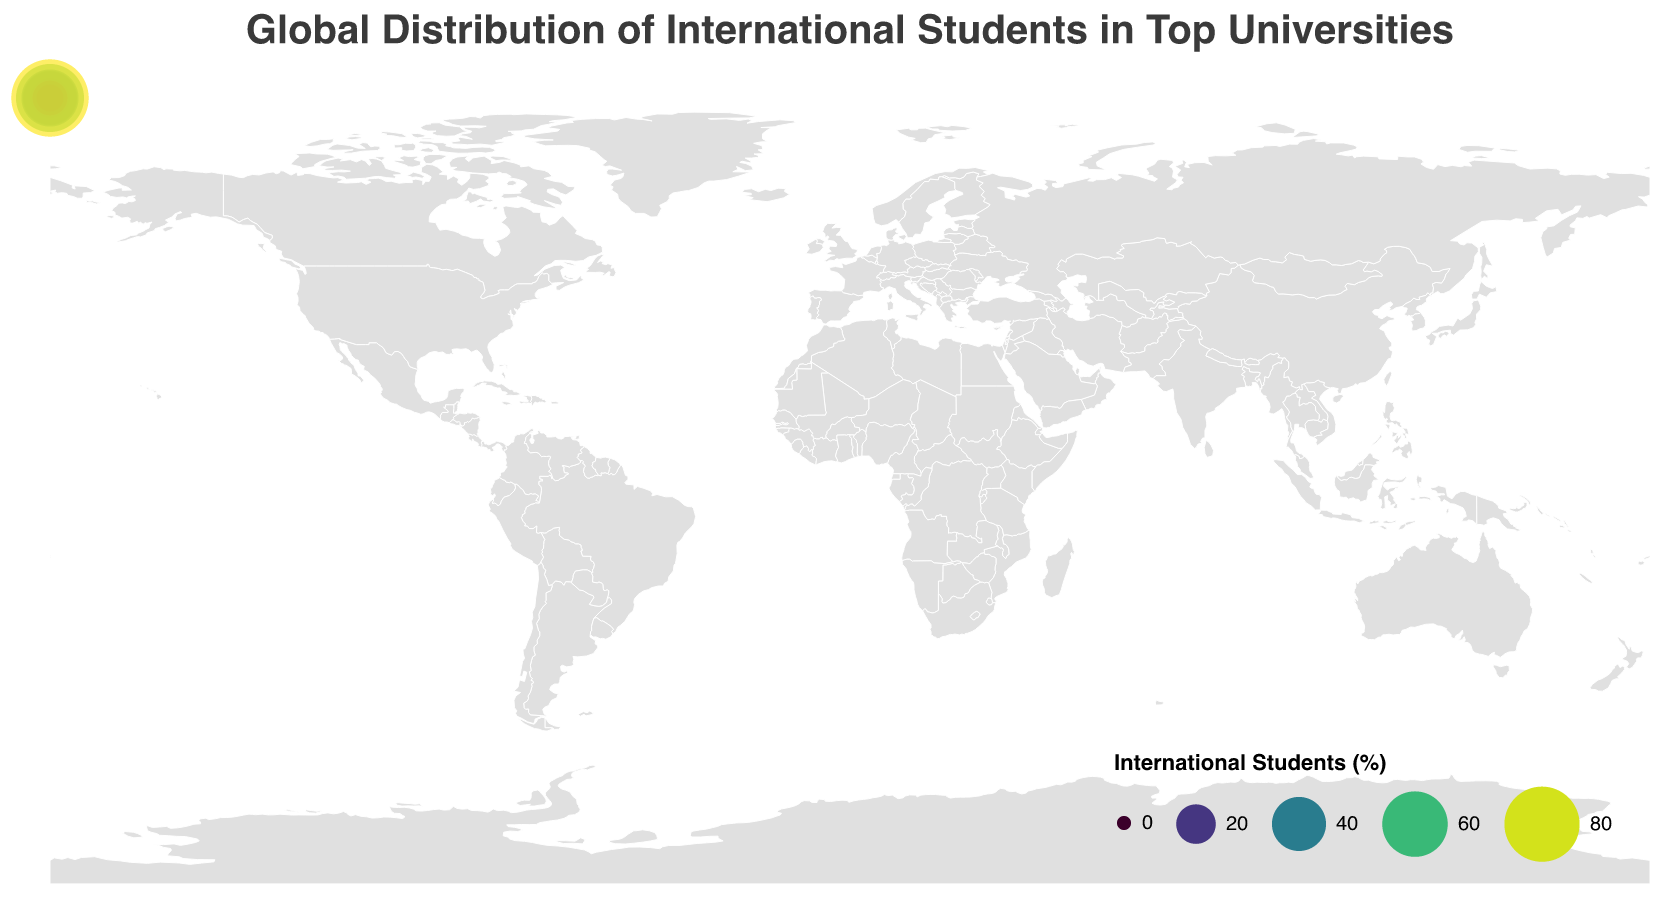what is the title of the figure? The title is written at the top of the figure and specifies the subject of the data being displayed.
Answer: "Global Distribution of International Students in Top Universities" Which university has the highest percentage of international students? By examining the size and color of the circles, the largest and most intense color indicates the highest value.
Answer: New York University Abu Dhabi Which countries have a university with an international student percentage above 40%? The countries corresponding to universities with circles that fall in the range above 40% based on the color scale and size.
Answer: United Arab Emirates, Spain, France, United Kingdom, Switzerland, and Australia What is the percentage of international students at University of Oxford? Locate University of Oxford on the plot and read the percentage value.
Answer: 41% How many universities have a percentage of international students less than 20%? Count the number of circles with sizes and colors indicative of less than 20%.
Answer: 7 Which university has a higher percentage of international students, University of Toronto or National University of Singapore? Compare the size and color of the circles representing University of Toronto and National University of Singapore.
Answer: University of Toronto What is the range of international student percentages shown in the plot? Identify the smallest and largest values from the plot's legend or data points.
Answer: 8% - 85% Compare the percentage of international students at Harvard University and Tsinghua University, which one is greater and by how much? Locate both universities on the plot and calculate the difference between their percentages.
Answer: Harvard University has 14% more Identify the university with a similar percentage of international students to ETH Zurich Locate ETH Zurich and identify another university with similar size and color of circle.
Answer: University of Melbourne What is the average percentage of international students among the universities in Europe? Select the relevant universities in Europe and calculate the average. List includes University of Oxford, ETH Zurich, Sciences Po, Technical University of Munich, University of Amsterdam, Bocconi University, and IE University.
Answer: (41 + 39 + 45 + 28 + 20 + 15 + 65)/7 ≈ 36.14% 